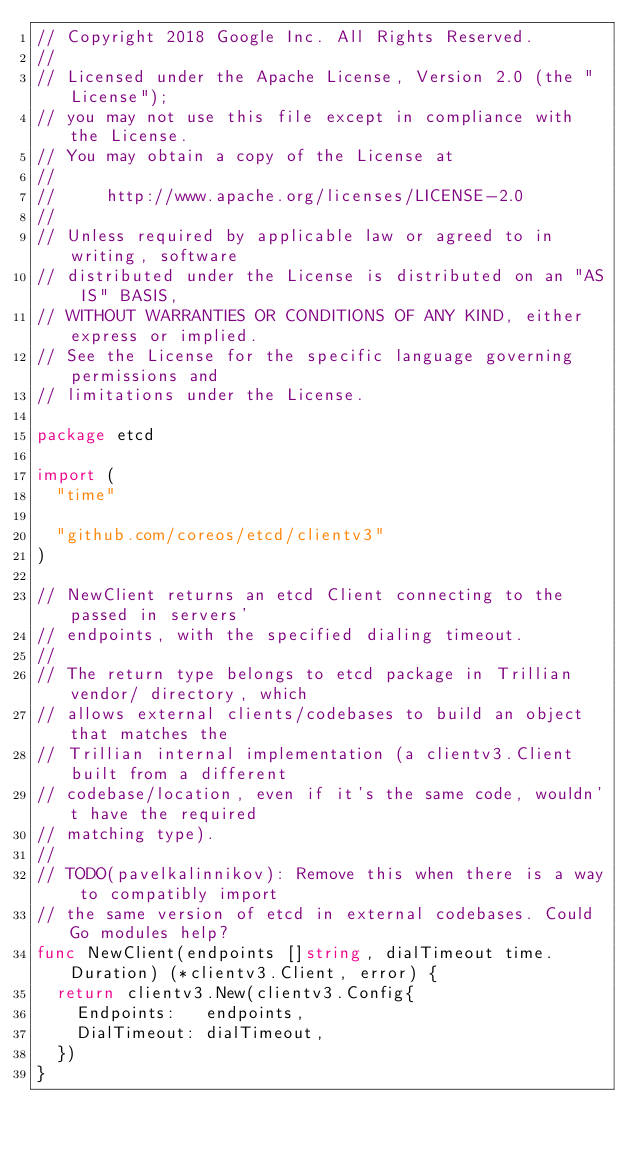<code> <loc_0><loc_0><loc_500><loc_500><_Go_>// Copyright 2018 Google Inc. All Rights Reserved.
//
// Licensed under the Apache License, Version 2.0 (the "License");
// you may not use this file except in compliance with the License.
// You may obtain a copy of the License at
//
//     http://www.apache.org/licenses/LICENSE-2.0
//
// Unless required by applicable law or agreed to in writing, software
// distributed under the License is distributed on an "AS IS" BASIS,
// WITHOUT WARRANTIES OR CONDITIONS OF ANY KIND, either express or implied.
// See the License for the specific language governing permissions and
// limitations under the License.

package etcd

import (
	"time"

	"github.com/coreos/etcd/clientv3"
)

// NewClient returns an etcd Client connecting to the passed in servers'
// endpoints, with the specified dialing timeout.
//
// The return type belongs to etcd package in Trillian vendor/ directory, which
// allows external clients/codebases to build an object that matches the
// Trillian internal implementation (a clientv3.Client built from a different
// codebase/location, even if it's the same code, wouldn't have the required
// matching type).
//
// TODO(pavelkalinnikov): Remove this when there is a way to compatibly import
// the same version of etcd in external codebases. Could Go modules help?
func NewClient(endpoints []string, dialTimeout time.Duration) (*clientv3.Client, error) {
	return clientv3.New(clientv3.Config{
		Endpoints:   endpoints,
		DialTimeout: dialTimeout,
	})
}
</code> 